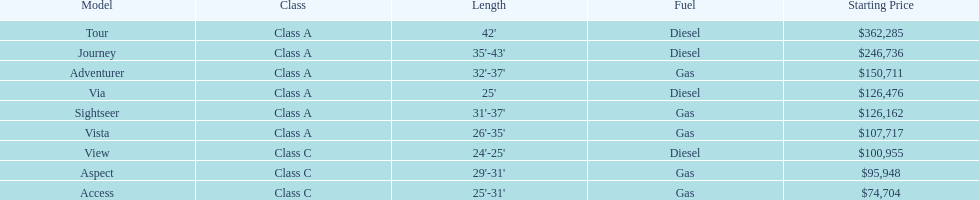Which model is at the top of the list with the highest starting price? Tour. 